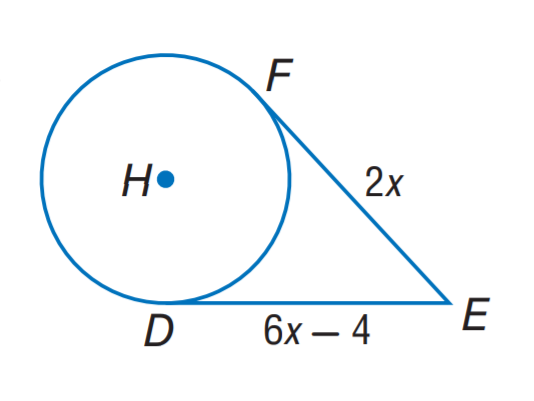Question: The segment is tangent to the circle. Find x.
Choices:
A. 1
B. 2
C. 3
D. 4
Answer with the letter. Answer: A 